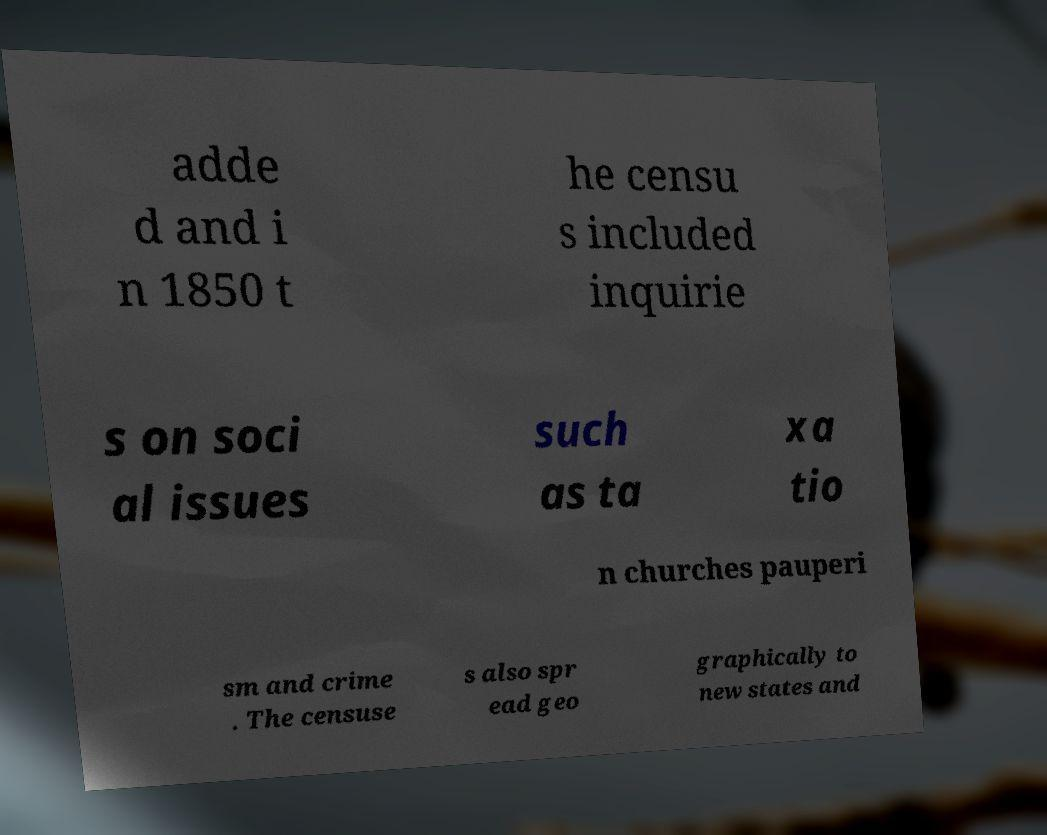Can you read and provide the text displayed in the image?This photo seems to have some interesting text. Can you extract and type it out for me? adde d and i n 1850 t he censu s included inquirie s on soci al issues such as ta xa tio n churches pauperi sm and crime . The censuse s also spr ead geo graphically to new states and 